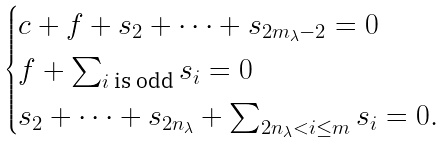Convert formula to latex. <formula><loc_0><loc_0><loc_500><loc_500>\begin{cases} c + f + s _ { 2 } + \cdots + s _ { 2 m _ { \lambda } - 2 } = 0 \\ f + \sum _ { i \text { is odd} } s _ { i } = 0 \\ s _ { 2 } + \cdots + s _ { 2 n _ { \lambda } } + \sum _ { 2 n _ { \lambda } < i \leq m } s _ { i } = 0 . \end{cases}</formula> 